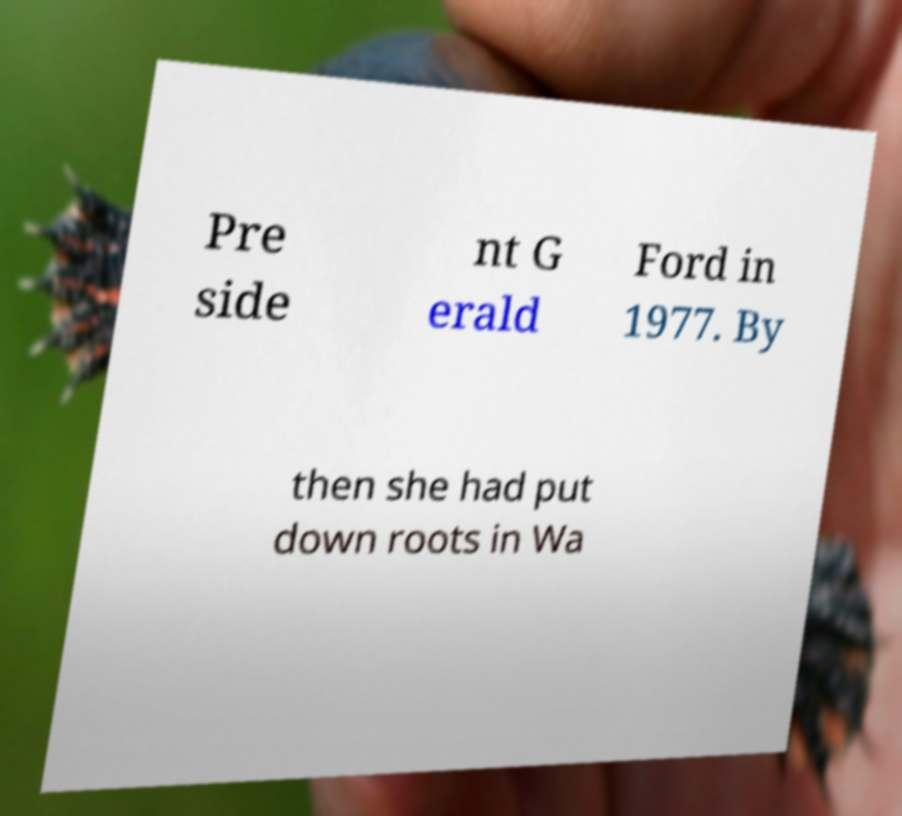For documentation purposes, I need the text within this image transcribed. Could you provide that? Pre side nt G erald Ford in 1977. By then she had put down roots in Wa 